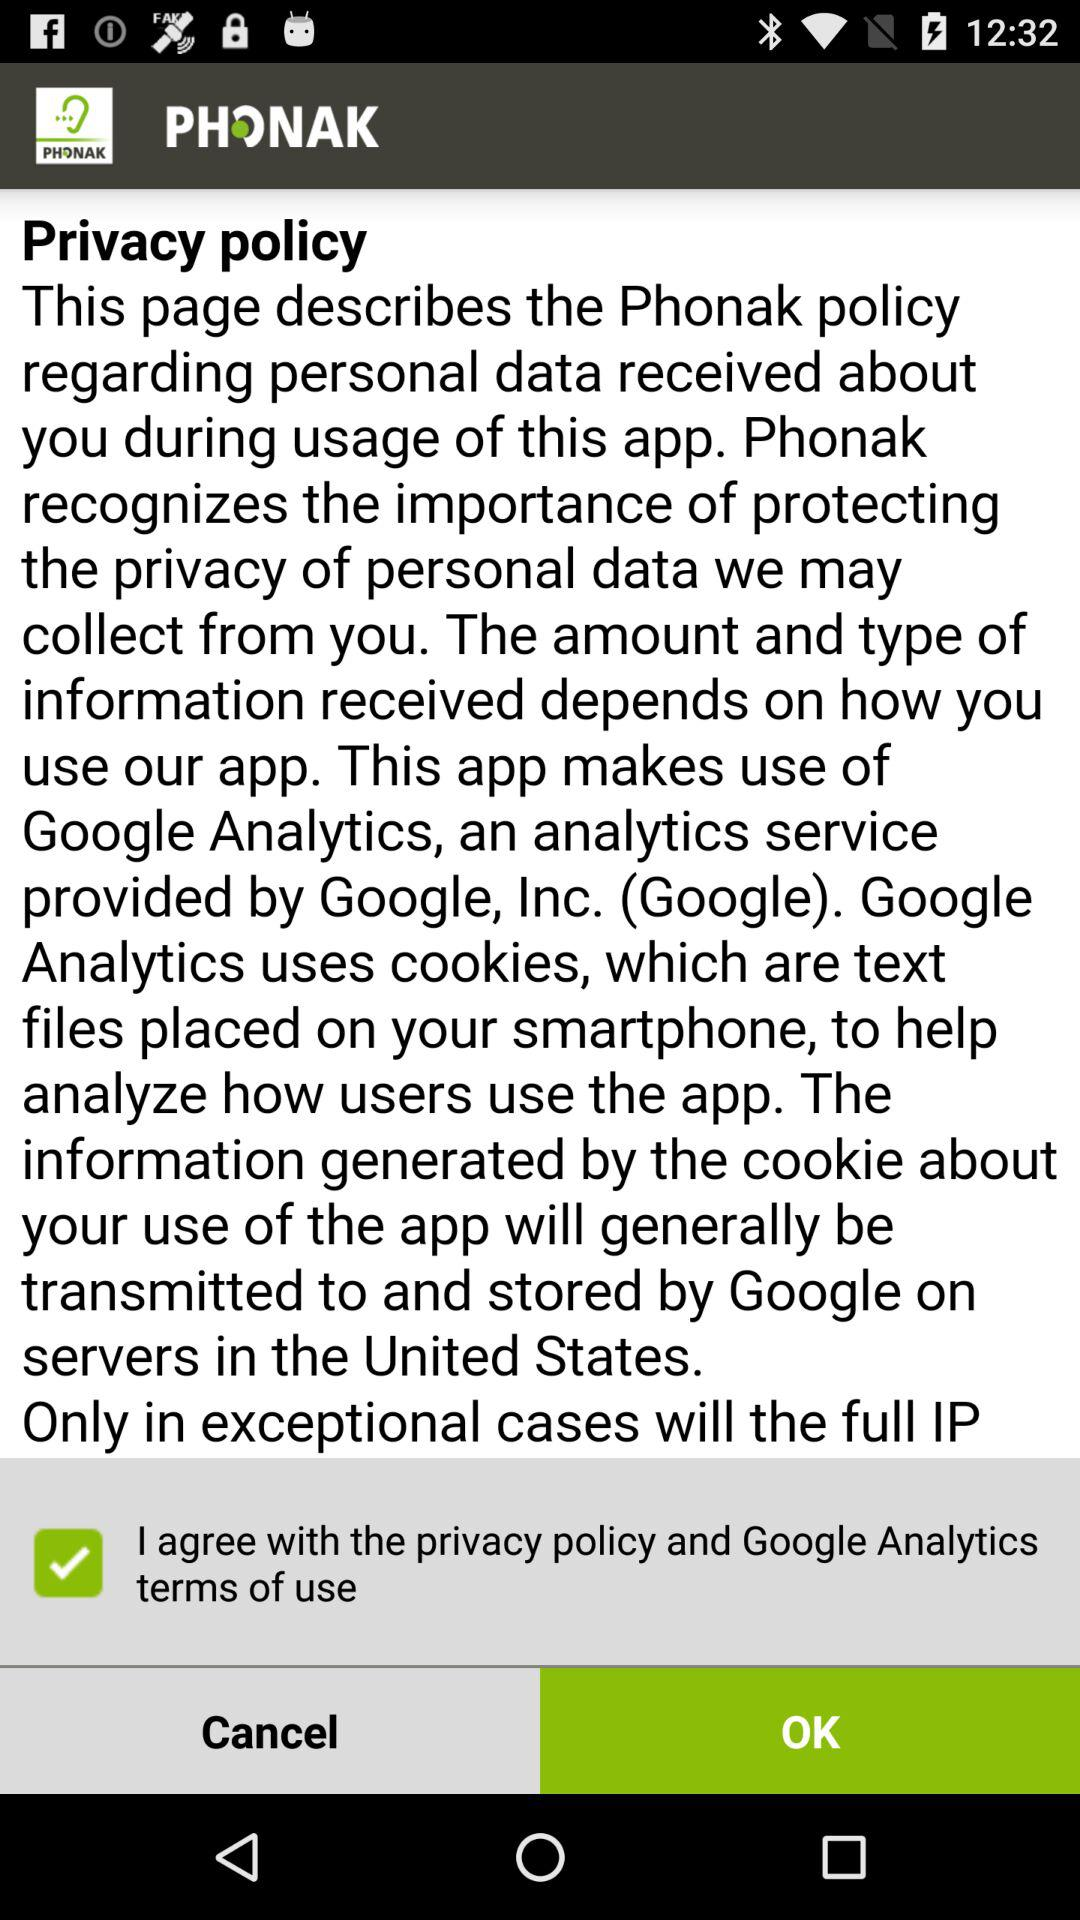Is "I agree with the privacy policy and Google Analytics terms of use" checked or unchecked?
Answer the question using a single word or phrase. It is checked. 